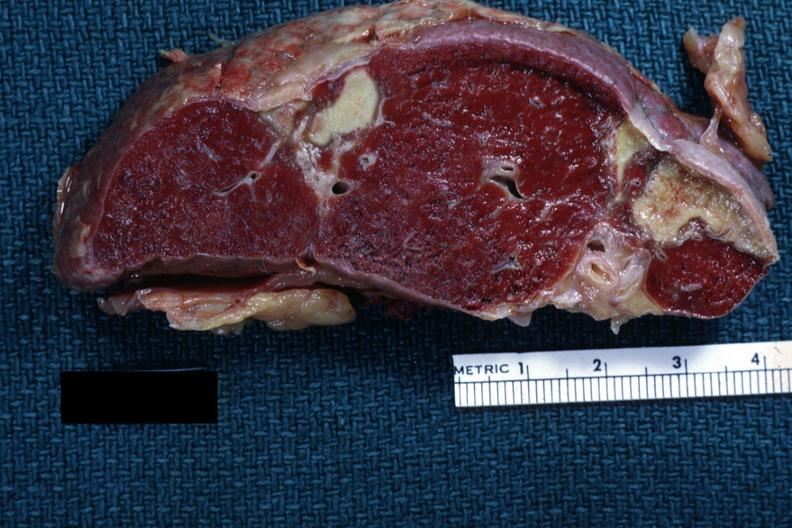what does this image show?
Answer the question using a single word or phrase. Excellentremote infarct with yellow centers 